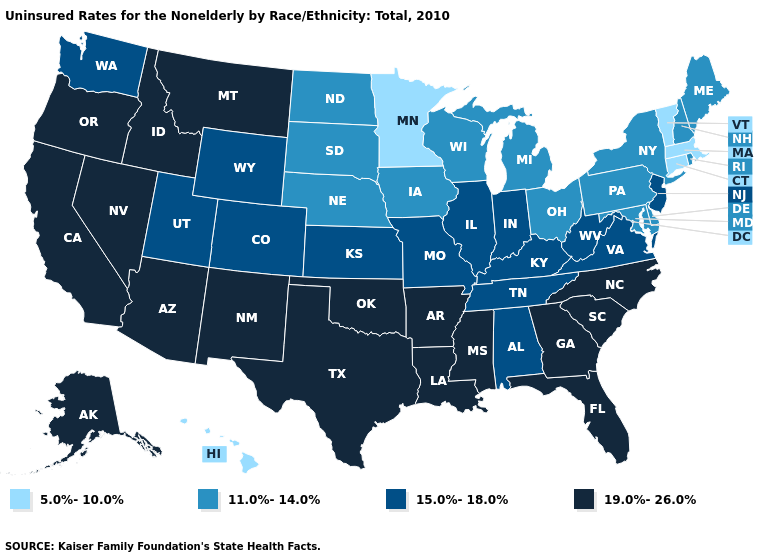Does Alaska have the same value as California?
Concise answer only. Yes. What is the highest value in states that border Texas?
Write a very short answer. 19.0%-26.0%. What is the lowest value in the MidWest?
Answer briefly. 5.0%-10.0%. Does Rhode Island have a lower value than Michigan?
Keep it brief. No. Does New Jersey have the highest value in the Northeast?
Give a very brief answer. Yes. Among the states that border New Hampshire , does Maine have the highest value?
Short answer required. Yes. Does the first symbol in the legend represent the smallest category?
Short answer required. Yes. Name the states that have a value in the range 11.0%-14.0%?
Keep it brief. Delaware, Iowa, Maine, Maryland, Michigan, Nebraska, New Hampshire, New York, North Dakota, Ohio, Pennsylvania, Rhode Island, South Dakota, Wisconsin. Does the map have missing data?
Concise answer only. No. Name the states that have a value in the range 11.0%-14.0%?
Answer briefly. Delaware, Iowa, Maine, Maryland, Michigan, Nebraska, New Hampshire, New York, North Dakota, Ohio, Pennsylvania, Rhode Island, South Dakota, Wisconsin. Is the legend a continuous bar?
Give a very brief answer. No. What is the highest value in the USA?
Be succinct. 19.0%-26.0%. Name the states that have a value in the range 5.0%-10.0%?
Short answer required. Connecticut, Hawaii, Massachusetts, Minnesota, Vermont. What is the highest value in states that border Ohio?
Concise answer only. 15.0%-18.0%. What is the value of Delaware?
Write a very short answer. 11.0%-14.0%. 